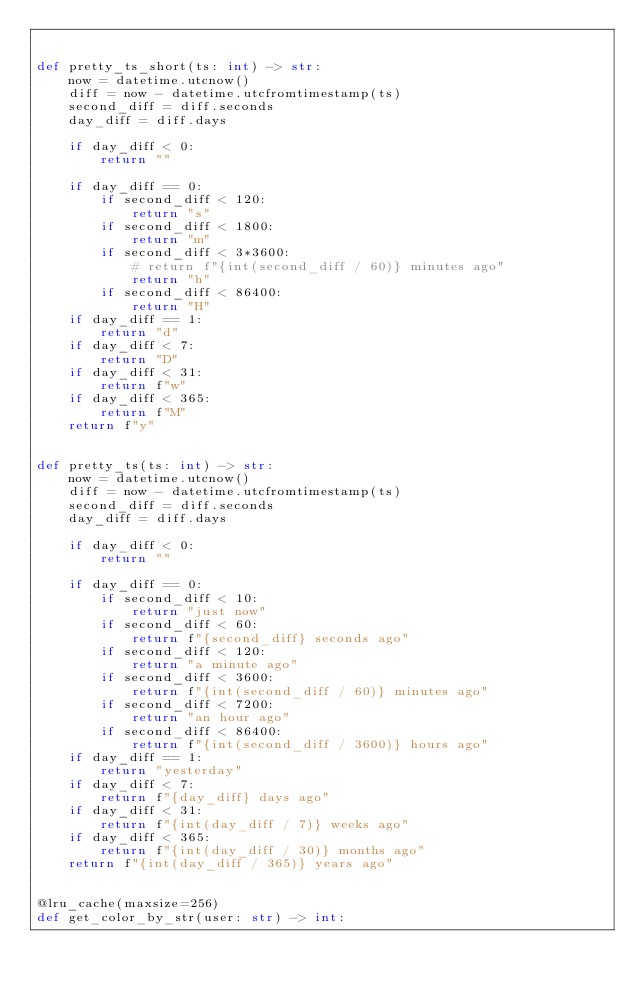<code> <loc_0><loc_0><loc_500><loc_500><_Python_>

def pretty_ts_short(ts: int) -> str:
    now = datetime.utcnow()
    diff = now - datetime.utcfromtimestamp(ts)
    second_diff = diff.seconds
    day_diff = diff.days

    if day_diff < 0:
        return ""

    if day_diff == 0:
        if second_diff < 120:
            return "s"
        if second_diff < 1800:
            return "m"
        if second_diff < 3*3600:
            # return f"{int(second_diff / 60)} minutes ago"
            return "h"
        if second_diff < 86400:
            return "H"
    if day_diff == 1:
        return "d"
    if day_diff < 7:
        return "D"
    if day_diff < 31:
        return f"w"
    if day_diff < 365:
        return f"M"
    return f"y"


def pretty_ts(ts: int) -> str:
    now = datetime.utcnow()
    diff = now - datetime.utcfromtimestamp(ts)
    second_diff = diff.seconds
    day_diff = diff.days

    if day_diff < 0:
        return ""

    if day_diff == 0:
        if second_diff < 10:
            return "just now"
        if second_diff < 60:
            return f"{second_diff} seconds ago"
        if second_diff < 120:
            return "a minute ago"
        if second_diff < 3600:
            return f"{int(second_diff / 60)} minutes ago"
        if second_diff < 7200:
            return "an hour ago"
        if second_diff < 86400:
            return f"{int(second_diff / 3600)} hours ago"
    if day_diff == 1:
        return "yesterday"
    if day_diff < 7:
        return f"{day_diff} days ago"
    if day_diff < 31:
        return f"{int(day_diff / 7)} weeks ago"
    if day_diff < 365:
        return f"{int(day_diff / 30)} months ago"
    return f"{int(day_diff / 365)} years ago"


@lru_cache(maxsize=256)
def get_color_by_str(user: str) -> int:</code> 